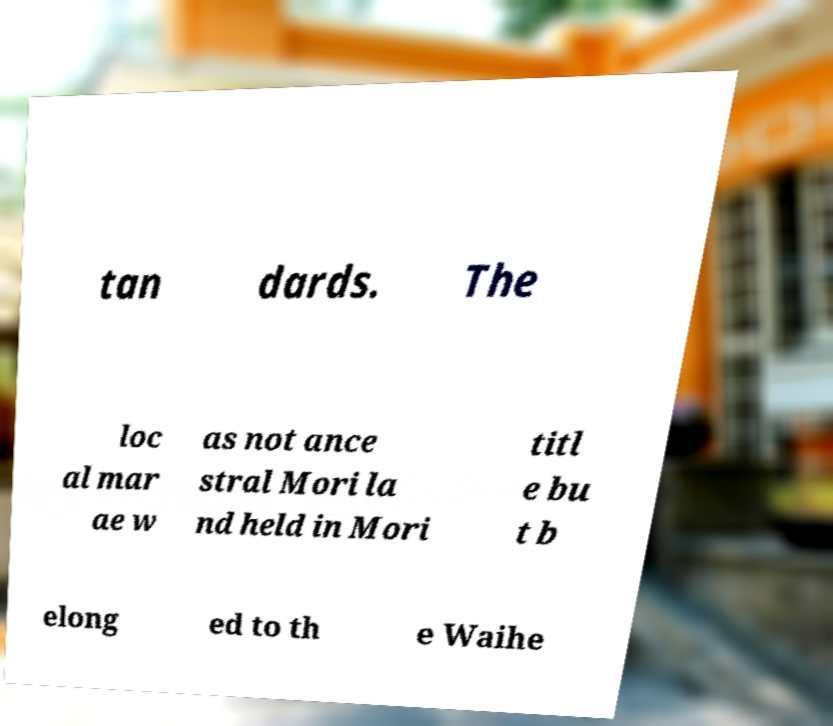Please read and relay the text visible in this image. What does it say? tan dards. The loc al mar ae w as not ance stral Mori la nd held in Mori titl e bu t b elong ed to th e Waihe 